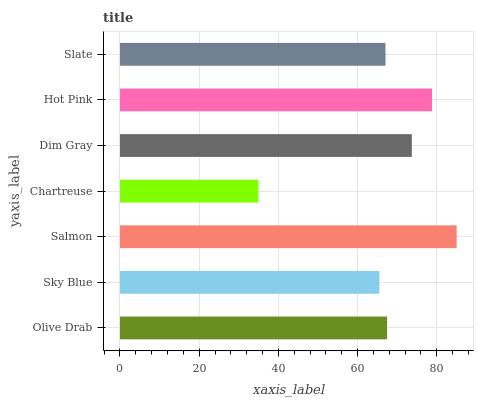Is Chartreuse the minimum?
Answer yes or no. Yes. Is Salmon the maximum?
Answer yes or no. Yes. Is Sky Blue the minimum?
Answer yes or no. No. Is Sky Blue the maximum?
Answer yes or no. No. Is Olive Drab greater than Sky Blue?
Answer yes or no. Yes. Is Sky Blue less than Olive Drab?
Answer yes or no. Yes. Is Sky Blue greater than Olive Drab?
Answer yes or no. No. Is Olive Drab less than Sky Blue?
Answer yes or no. No. Is Olive Drab the high median?
Answer yes or no. Yes. Is Olive Drab the low median?
Answer yes or no. Yes. Is Hot Pink the high median?
Answer yes or no. No. Is Chartreuse the low median?
Answer yes or no. No. 